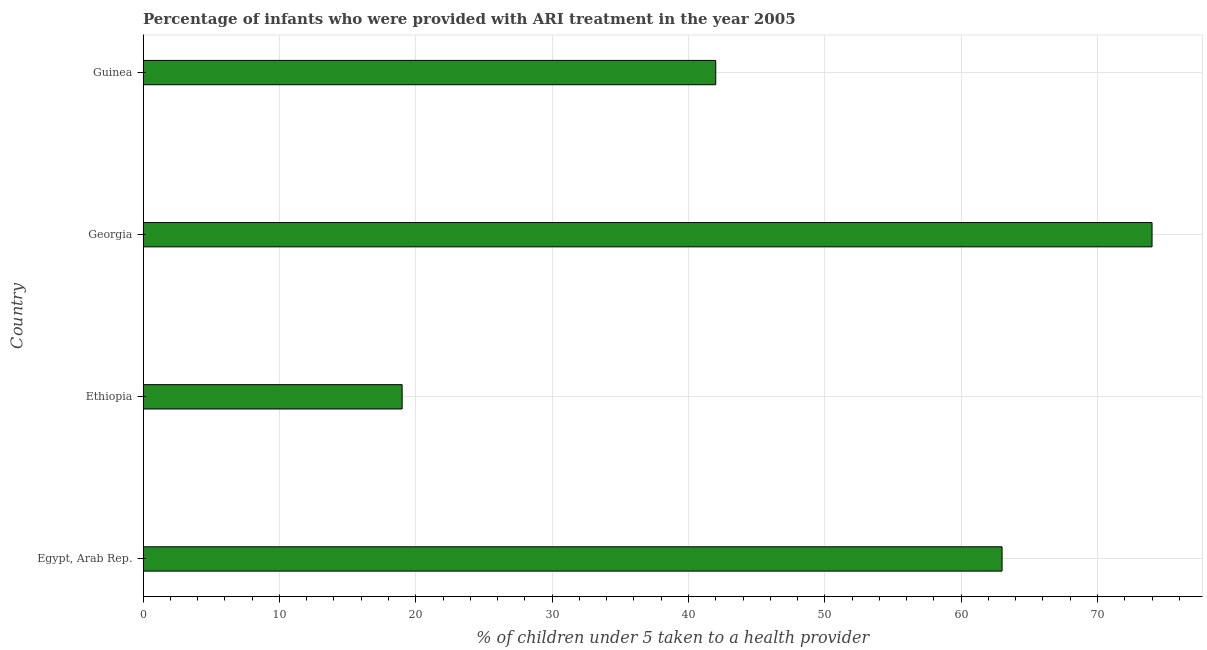What is the title of the graph?
Ensure brevity in your answer.  Percentage of infants who were provided with ARI treatment in the year 2005. What is the label or title of the X-axis?
Your answer should be very brief. % of children under 5 taken to a health provider. What is the label or title of the Y-axis?
Your answer should be very brief. Country. Across all countries, what is the minimum percentage of children who were provided with ari treatment?
Make the answer very short. 19. In which country was the percentage of children who were provided with ari treatment maximum?
Make the answer very short. Georgia. In which country was the percentage of children who were provided with ari treatment minimum?
Your answer should be compact. Ethiopia. What is the sum of the percentage of children who were provided with ari treatment?
Your answer should be compact. 198. What is the difference between the percentage of children who were provided with ari treatment in Egypt, Arab Rep. and Georgia?
Offer a terse response. -11. What is the average percentage of children who were provided with ari treatment per country?
Offer a very short reply. 49.5. What is the median percentage of children who were provided with ari treatment?
Offer a very short reply. 52.5. In how many countries, is the percentage of children who were provided with ari treatment greater than 10 %?
Keep it short and to the point. 4. What is the ratio of the percentage of children who were provided with ari treatment in Egypt, Arab Rep. to that in Georgia?
Keep it short and to the point. 0.85. Is the difference between the percentage of children who were provided with ari treatment in Egypt, Arab Rep. and Guinea greater than the difference between any two countries?
Offer a very short reply. No. What is the difference between the highest and the lowest percentage of children who were provided with ari treatment?
Give a very brief answer. 55. In how many countries, is the percentage of children who were provided with ari treatment greater than the average percentage of children who were provided with ari treatment taken over all countries?
Provide a succinct answer. 2. What is the % of children under 5 taken to a health provider of Egypt, Arab Rep.?
Offer a very short reply. 63. What is the % of children under 5 taken to a health provider in Georgia?
Make the answer very short. 74. What is the % of children under 5 taken to a health provider of Guinea?
Offer a very short reply. 42. What is the difference between the % of children under 5 taken to a health provider in Egypt, Arab Rep. and Guinea?
Your answer should be very brief. 21. What is the difference between the % of children under 5 taken to a health provider in Ethiopia and Georgia?
Offer a very short reply. -55. What is the difference between the % of children under 5 taken to a health provider in Ethiopia and Guinea?
Your answer should be very brief. -23. What is the ratio of the % of children under 5 taken to a health provider in Egypt, Arab Rep. to that in Ethiopia?
Give a very brief answer. 3.32. What is the ratio of the % of children under 5 taken to a health provider in Egypt, Arab Rep. to that in Georgia?
Your answer should be very brief. 0.85. What is the ratio of the % of children under 5 taken to a health provider in Egypt, Arab Rep. to that in Guinea?
Keep it short and to the point. 1.5. What is the ratio of the % of children under 5 taken to a health provider in Ethiopia to that in Georgia?
Provide a succinct answer. 0.26. What is the ratio of the % of children under 5 taken to a health provider in Ethiopia to that in Guinea?
Ensure brevity in your answer.  0.45. What is the ratio of the % of children under 5 taken to a health provider in Georgia to that in Guinea?
Offer a very short reply. 1.76. 